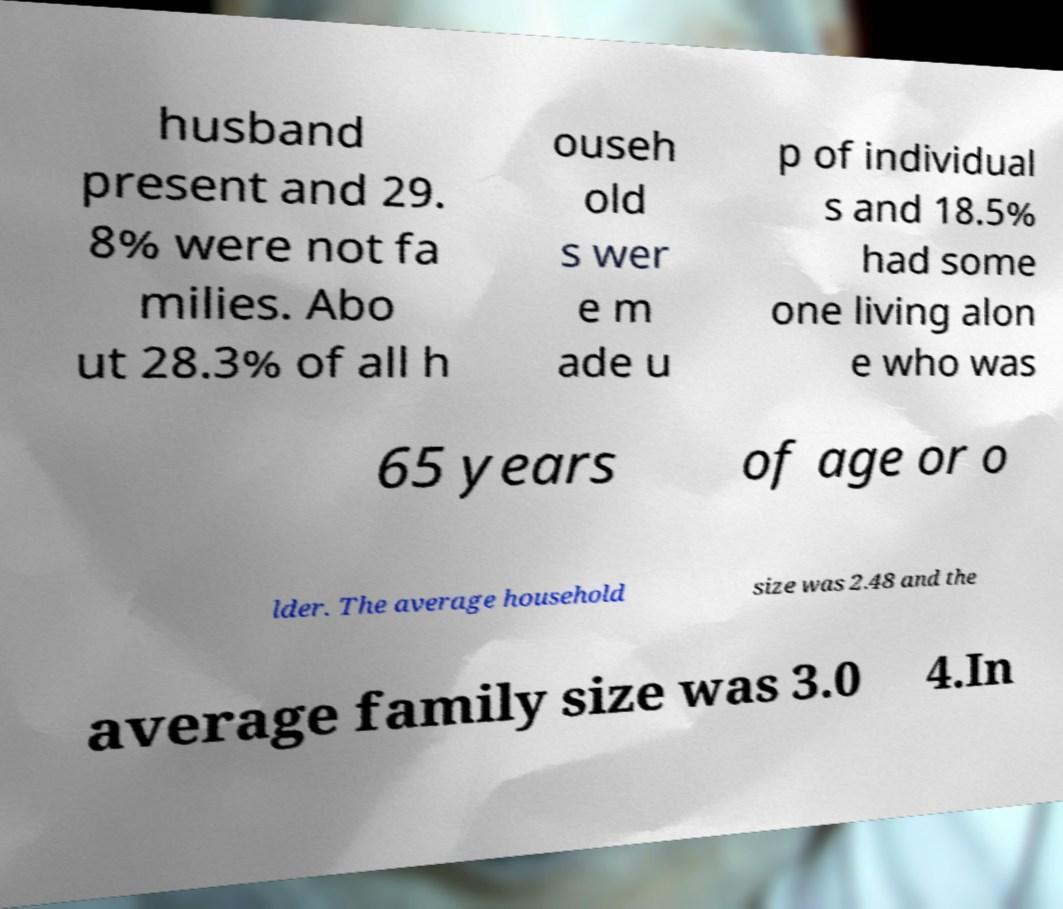Please read and relay the text visible in this image. What does it say? husband present and 29. 8% were not fa milies. Abo ut 28.3% of all h ouseh old s wer e m ade u p of individual s and 18.5% had some one living alon e who was 65 years of age or o lder. The average household size was 2.48 and the average family size was 3.0 4.In 